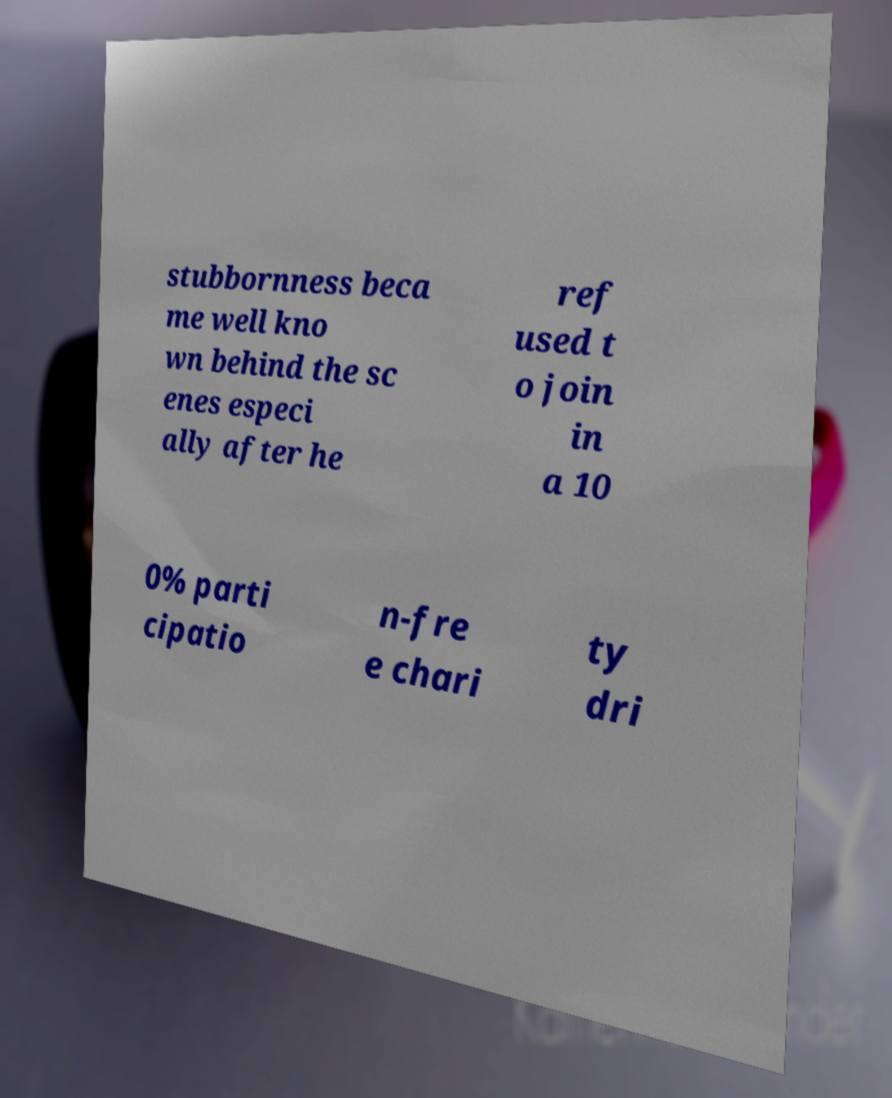Can you accurately transcribe the text from the provided image for me? stubbornness beca me well kno wn behind the sc enes especi ally after he ref used t o join in a 10 0% parti cipatio n-fre e chari ty dri 